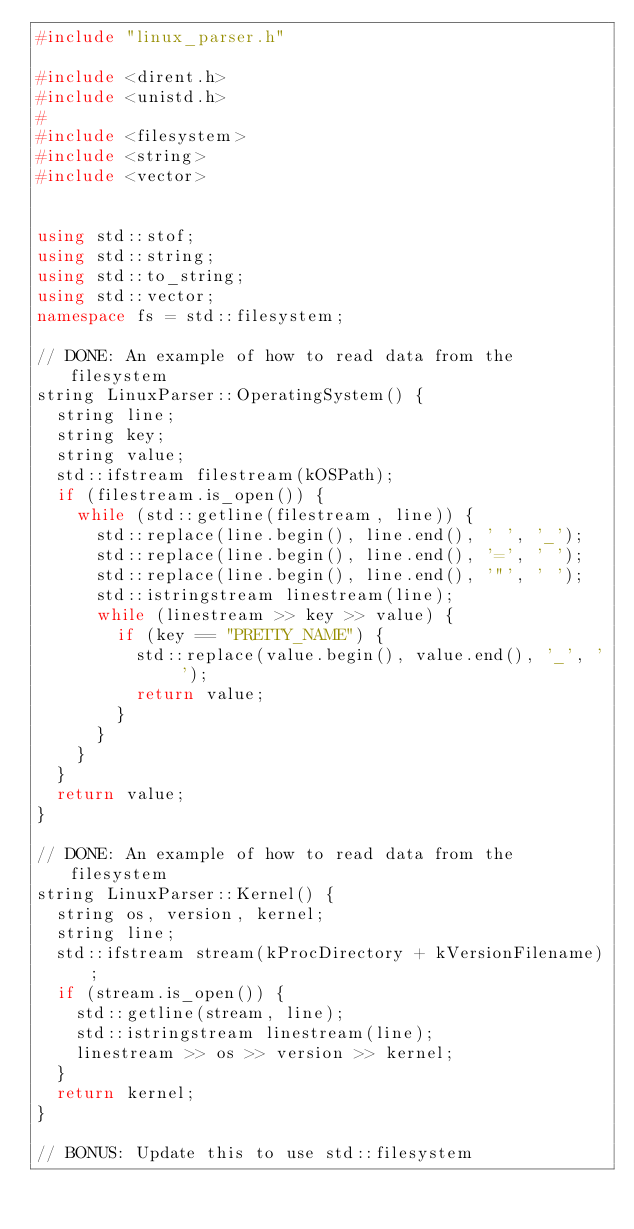<code> <loc_0><loc_0><loc_500><loc_500><_C++_>#include "linux_parser.h"

#include <dirent.h>
#include <unistd.h>
#
#include <filesystem>
#include <string>
#include <vector>


using std::stof;
using std::string;
using std::to_string;
using std::vector;
namespace fs = std::filesystem;

// DONE: An example of how to read data from the filesystem
string LinuxParser::OperatingSystem() {
  string line;
  string key;
  string value;
  std::ifstream filestream(kOSPath);
  if (filestream.is_open()) {
    while (std::getline(filestream, line)) {
      std::replace(line.begin(), line.end(), ' ', '_');
      std::replace(line.begin(), line.end(), '=', ' ');
      std::replace(line.begin(), line.end(), '"', ' ');
      std::istringstream linestream(line);
      while (linestream >> key >> value) {
        if (key == "PRETTY_NAME") {
          std::replace(value.begin(), value.end(), '_', ' ');
          return value;
        }
      }
    }
  }
  return value;
}

// DONE: An example of how to read data from the filesystem
string LinuxParser::Kernel() {
  string os, version, kernel;
  string line;
  std::ifstream stream(kProcDirectory + kVersionFilename);
  if (stream.is_open()) {
    std::getline(stream, line);
    std::istringstream linestream(line);
    linestream >> os >> version >> kernel;
  }
  return kernel;
}

// BONUS: Update this to use std::filesystem</code> 